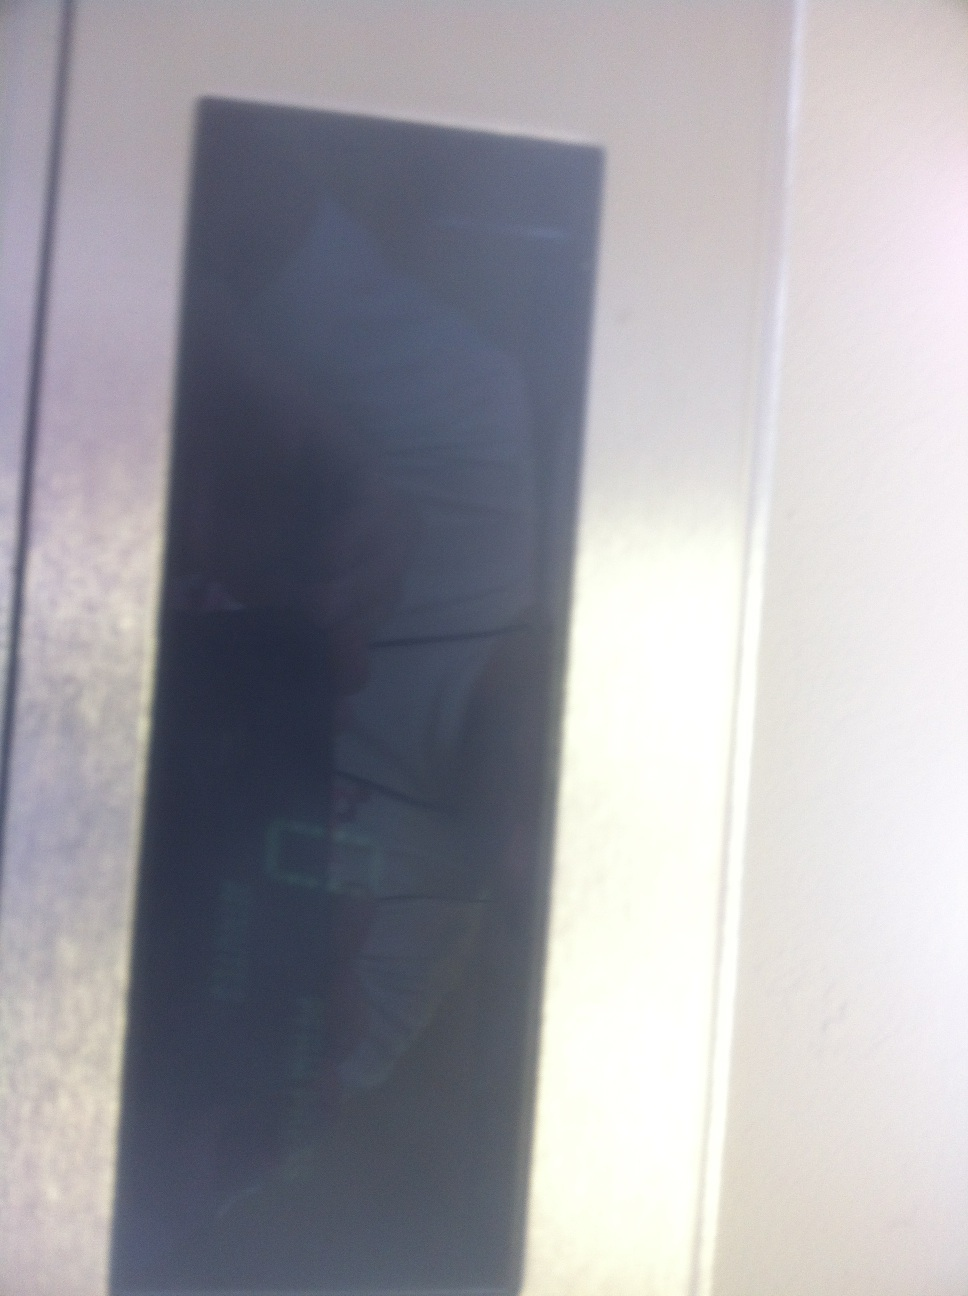Can you describe what the reflection in the display indicates? The reflection in the display seems to show a person taking the photo, partially obscured by the glare from the surroundings. It appears to be an indoor setting with some ambient light affecting the visibility of the display. 